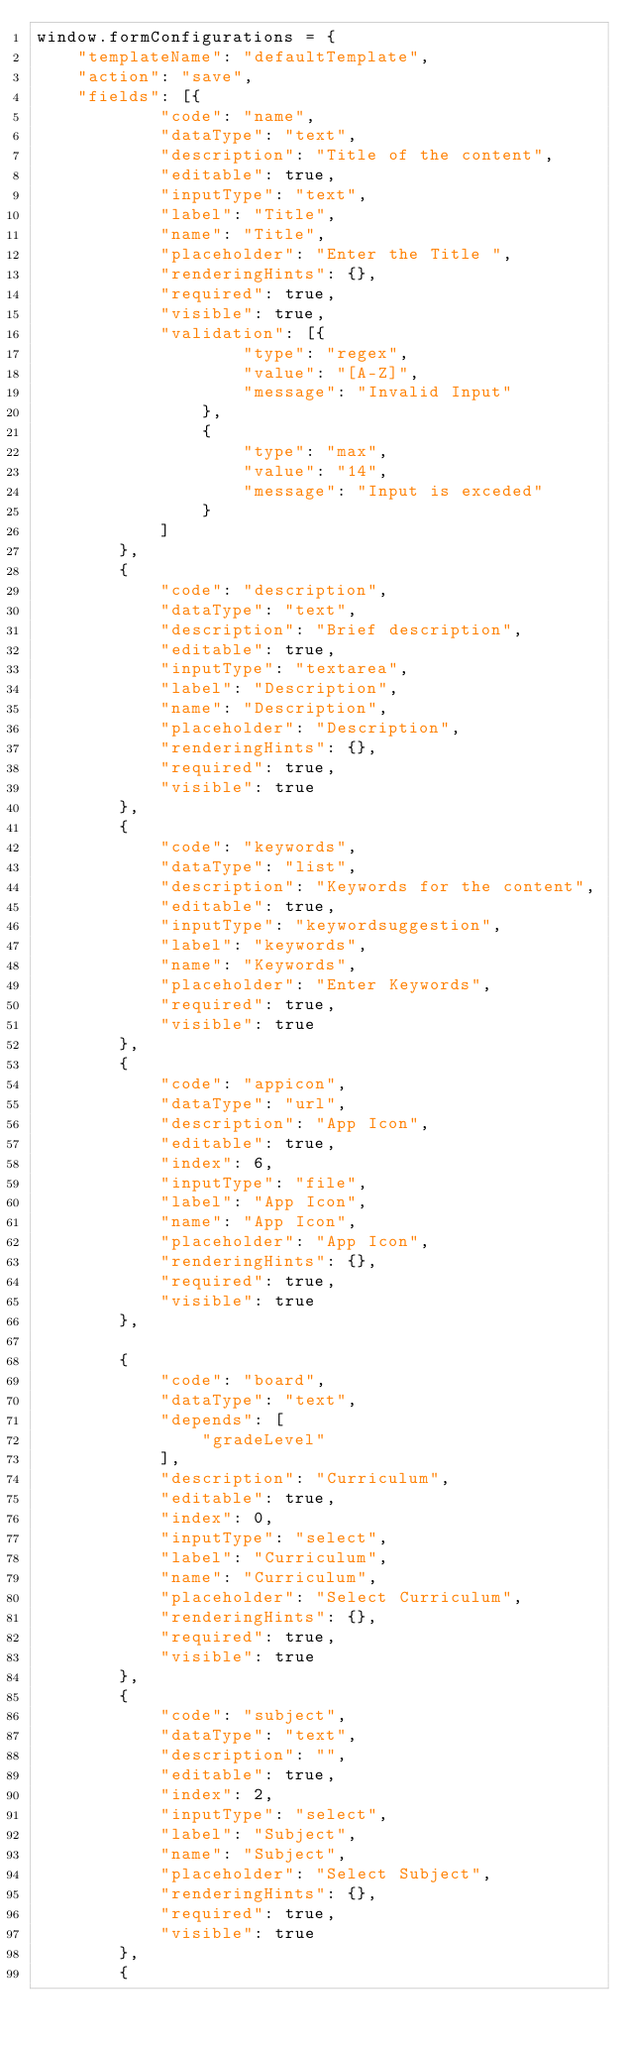<code> <loc_0><loc_0><loc_500><loc_500><_JavaScript_>window.formConfigurations = {
    "templateName": "defaultTemplate",
    "action": "save",
    "fields": [{
            "code": "name",
            "dataType": "text",
            "description": "Title of the content",
            "editable": true,
            "inputType": "text",
            "label": "Title",
            "name": "Title",
            "placeholder": "Enter the Title ",
            "renderingHints": {},
            "required": true,
            "visible": true,
            "validation": [{
                    "type": "regex",
                    "value": "[A-Z]",
                    "message": "Invalid Input"
                },
                {
                    "type": "max",
                    "value": "14",
                    "message": "Input is exceded"
                }
            ]
        },
        {
            "code": "description",
            "dataType": "text",
            "description": "Brief description",
            "editable": true,
            "inputType": "textarea",
            "label": "Description",
            "name": "Description",
            "placeholder": "Description",
            "renderingHints": {},
            "required": true,
            "visible": true
        },
        {
            "code": "keywords",
            "dataType": "list",
            "description": "Keywords for the content",
            "editable": true,
            "inputType": "keywordsuggestion",
            "label": "keywords",
            "name": "Keywords",
            "placeholder": "Enter Keywords",
            "required": true,
            "visible": true
        },
        {
            "code": "appicon",
            "dataType": "url",
            "description": "App Icon",
            "editable": true,
            "index": 6,
            "inputType": "file",
            "label": "App Icon",
            "name": "App Icon",
            "placeholder": "App Icon",
            "renderingHints": {},
            "required": true,
            "visible": true
        },

        {
            "code": "board",
            "dataType": "text",
            "depends": [
                "gradeLevel"
            ],
            "description": "Curriculum",
            "editable": true,
            "index": 0,
            "inputType": "select",
            "label": "Curriculum",
            "name": "Curriculum",
            "placeholder": "Select Curriculum",
            "renderingHints": {},
            "required": true,
            "visible": true
        },
        {
            "code": "subject",
            "dataType": "text",
            "description": "",
            "editable": true,
            "index": 2,
            "inputType": "select",
            "label": "Subject",
            "name": "Subject",
            "placeholder": "Select Subject",
            "renderingHints": {},
            "required": true,
            "visible": true
        },
        {</code> 